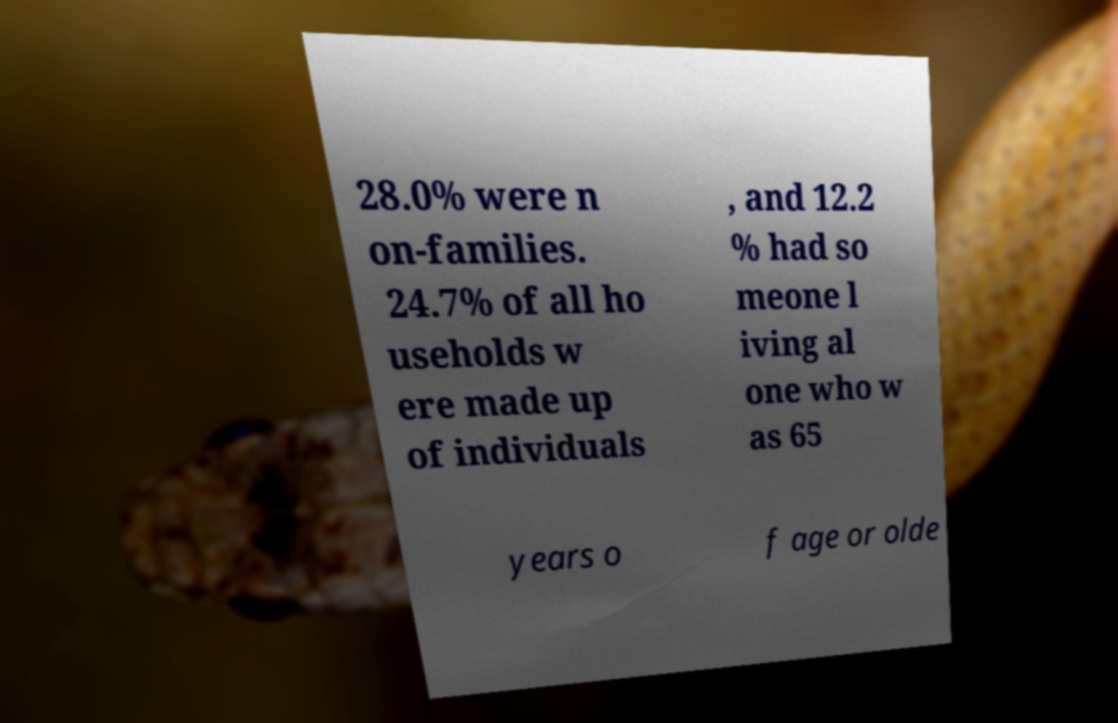Could you extract and type out the text from this image? 28.0% were n on-families. 24.7% of all ho useholds w ere made up of individuals , and 12.2 % had so meone l iving al one who w as 65 years o f age or olde 